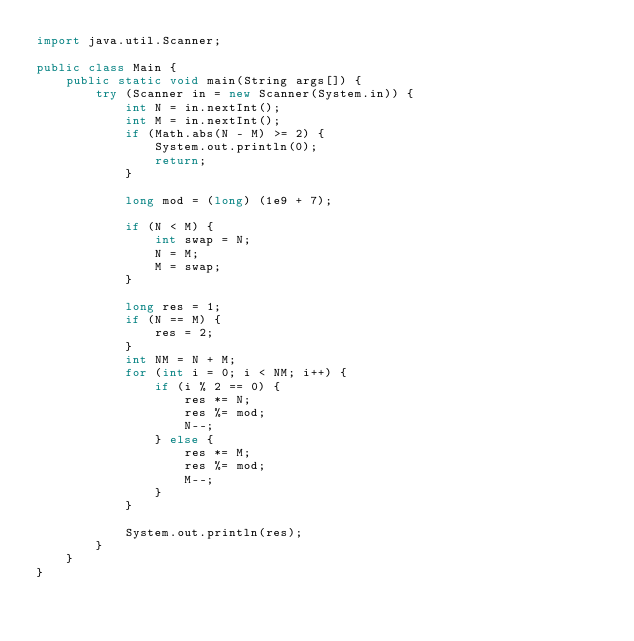Convert code to text. <code><loc_0><loc_0><loc_500><loc_500><_Java_>import java.util.Scanner;

public class Main {
    public static void main(String args[]) {
        try (Scanner in = new Scanner(System.in)) {
            int N = in.nextInt();
            int M = in.nextInt();
            if (Math.abs(N - M) >= 2) {
                System.out.println(0);
                return;
            }

            long mod = (long) (1e9 + 7);

            if (N < M) {
                int swap = N;
                N = M;
                M = swap;
            }

            long res = 1;
            if (N == M) {
                res = 2;
            }
            int NM = N + M;
            for (int i = 0; i < NM; i++) {
                if (i % 2 == 0) {
                    res *= N;
                    res %= mod;
                    N--;
                } else {
                    res *= M;
                    res %= mod;
                    M--;
                }
            }

            System.out.println(res);
        }
    }
}
</code> 